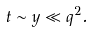<formula> <loc_0><loc_0><loc_500><loc_500>t \sim y \ll q ^ { 2 } .</formula> 